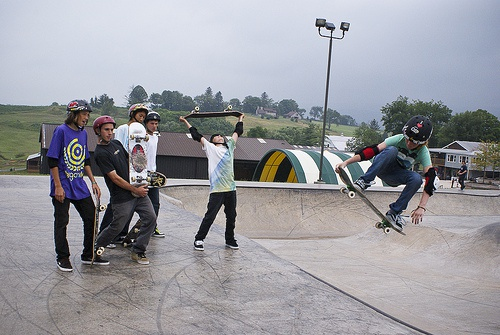Describe the objects in this image and their specific colors. I can see people in lightgray, black, gray, darkgray, and navy tones, people in lightgray, black, navy, darkblue, and gray tones, people in lightgray, black, gray, maroon, and brown tones, people in lightgray, black, darkgray, and gray tones, and skateboard in lightgray, darkgray, gray, and black tones in this image. 